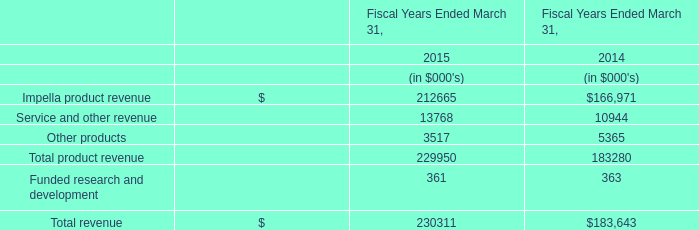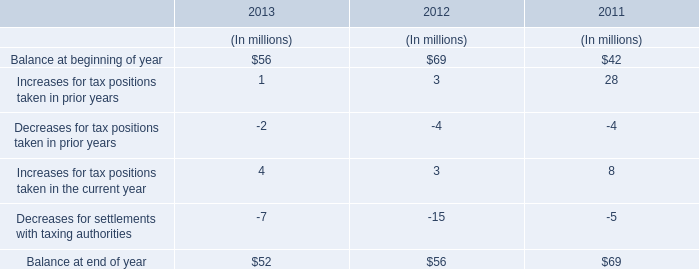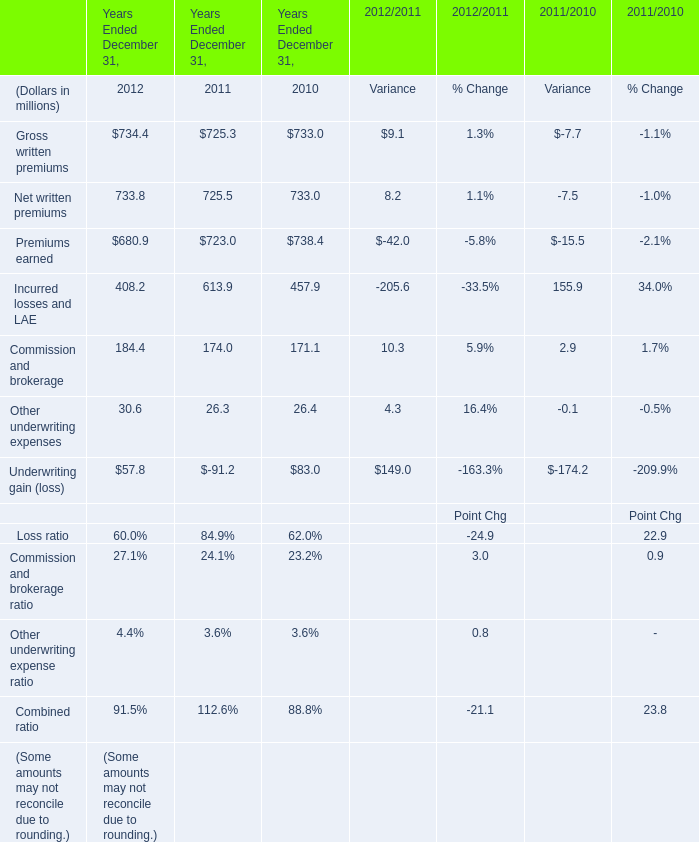What is the ratio of Gross written premiums to the Balance at beginning of year in 2012 ? 
Computations: (734.4 / 69)
Answer: 10.64348. 